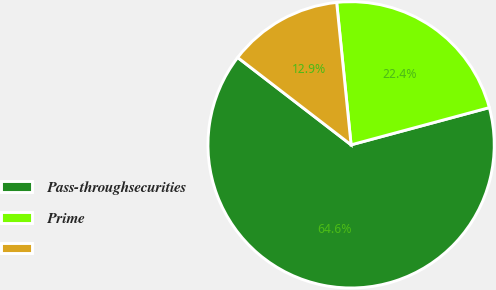Convert chart. <chart><loc_0><loc_0><loc_500><loc_500><pie_chart><fcel>Pass-throughsecurities<fcel>Prime<fcel>Unnamed: 2<nl><fcel>64.63%<fcel>22.42%<fcel>12.95%<nl></chart> 